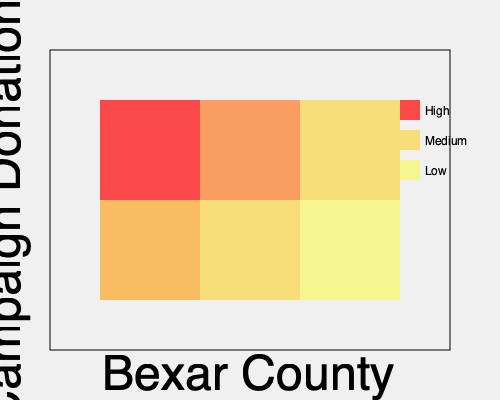Based on the heat map of campaign donations in Bexar County, which area of the county appears to have the highest concentration of campaign contributions, and what factors might contribute to this pattern? To answer this question, let's analyze the heat map step-by-step:

1. Interpretation of the heat map:
   - The map is divided into a 3x2 grid representing different areas of Bexar County.
   - The color intensity represents the level of campaign donations, with darker colors indicating higher contributions.

2. Identifying the area with the highest concentration:
   - The top-left square (northwest area) has the darkest red color, indicating the highest concentration of campaign donations.

3. Factors that might contribute to this pattern:
   a) Demographics:
      - This area likely has a higher concentration of affluent residents who can afford larger donations.
      - It may have a higher population density, resulting in more potential donors.

   b) Economic factors:
      - The presence of business districts or corporate headquarters could lead to more corporate donations.
      - Higher property values in this area might correlate with greater disposable income for political contributions.

   c) Political engagement:
      - Residents in this area may have a higher level of political involvement or interest.
      - There could be a concentration of politically active community organizations or clubs.

   d) Candidate focus:
      - Candidates might focus their fundraising efforts in this area due to past success or perceived potential.
      - Local politicians or influential figures from this area might drive higher donation rates.

   e) Education and awareness:
      - Higher education levels in this area could correlate with increased political awareness and donation tendencies.
      - Better access to information about campaigns and donation opportunities might exist here.

4. Implications for campaign strategies:
   - Campaigns might target this area more intensively for fundraising events.
   - Tailored messaging or policy proposals could be developed to appeal to donors in this region.

5. Considerations for political equity:
   - The concentration of donations in one area might raise questions about political representation and influence across the county.
   - Campaigns and policymakers should consider strategies to engage with and represent all areas of the county equally.
Answer: Northwest area; factors include demographics, economic conditions, political engagement, candidate focus, and education levels. 